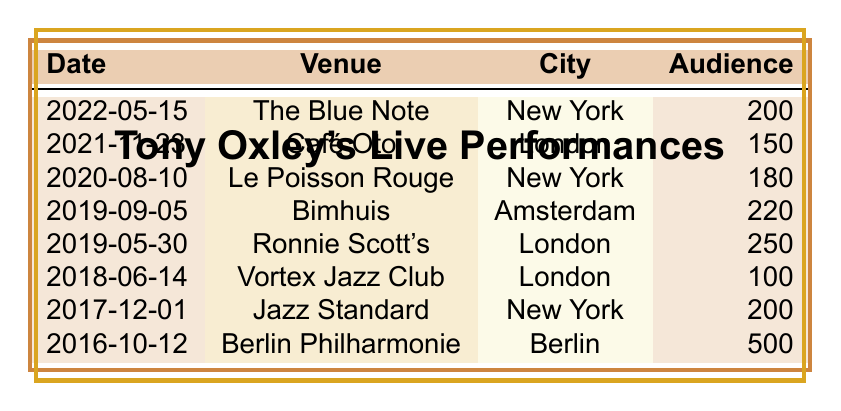What venue had the largest audience size for Tony Oxley's performances? The table indicates several performances with different audience sizes. By comparing the audience sizes, I see that the Berlin Philharmonie had the largest audience size of 500.
Answer: Berlin Philharmonie Which city hosted the most performances by Tony Oxley? The performances in London were from Café Oto, Ronnie Scott's, and Vortex Jazz Club, totaling three performances. New York hosted two performances (The Blue Note and Jazz Standard). Since London has more, it is the city with the most performances.
Answer: London What is the average audience size across all performances? To find the average audience size, sum all audience sizes: 200 + 150 + 180 + 220 + 250 + 100 + 200 + 500 = 1800. There are 8 performances in total, so the average is 1800/8 = 225.
Answer: 225 Did Tony Oxley perform in Amsterdam? By checking the table, I see that there is one performance listed in Amsterdam at the Bimhuis on September 5, 2019. Therefore, the answer is yes.
Answer: Yes How many performances had an audience size of 250 or more? Looking at the audience sizes in the table, I find that there are three performances with an audience size of 250 or more: Ronnie Scott's (250) and Berlin Philharmonie (500). Therefore, the total number is 2.
Answer: 2 